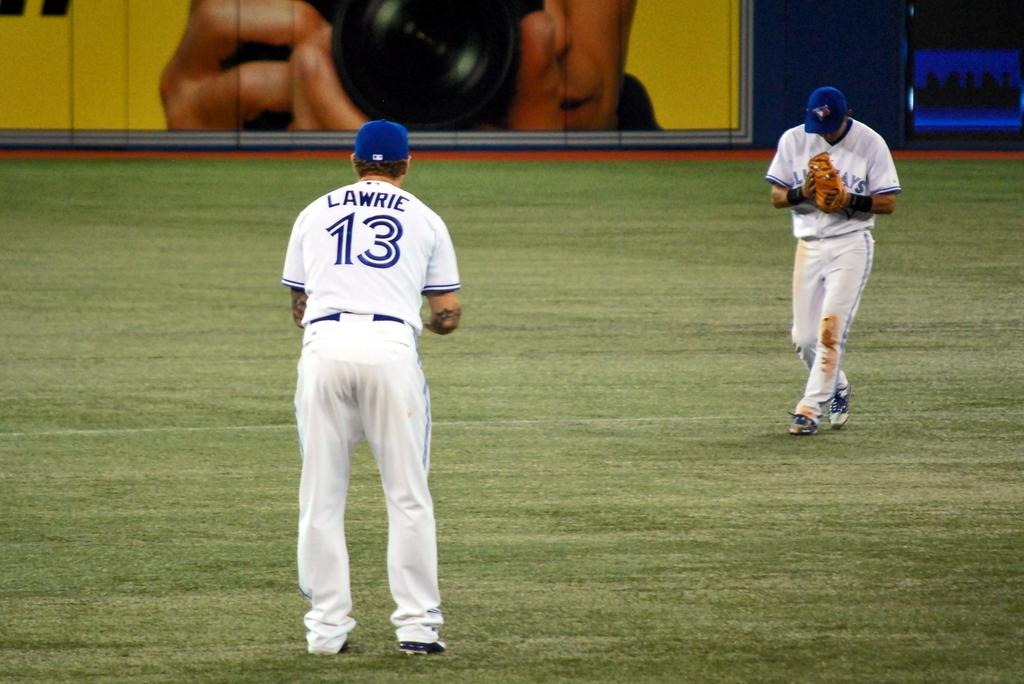<image>
Share a concise interpretation of the image provided. Two Bluejays players celebrate after the team made a catch to end the inning. 